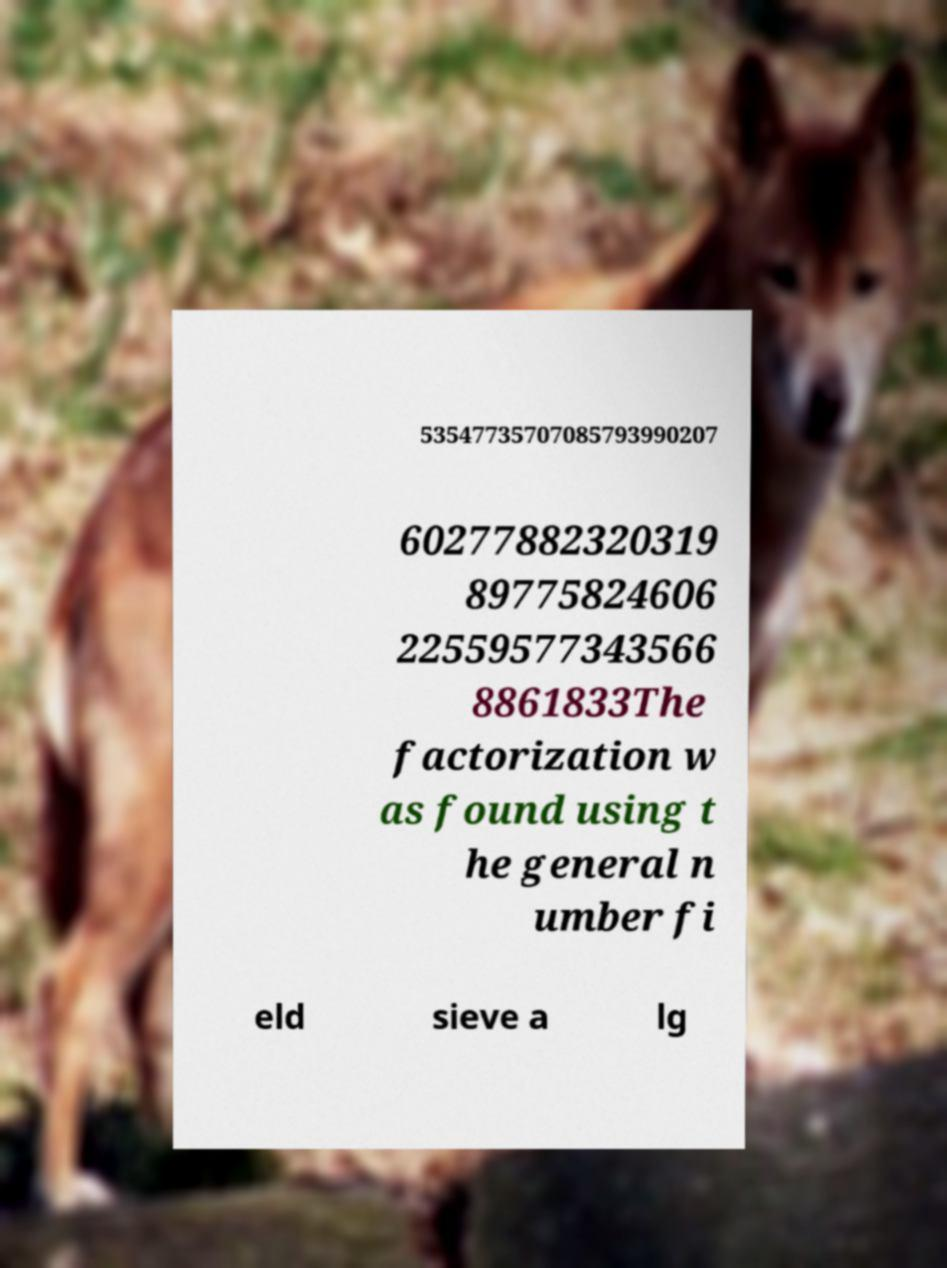I need the written content from this picture converted into text. Can you do that? 53547735707085793990207 60277882320319 89775824606 22559577343566 8861833The factorization w as found using t he general n umber fi eld sieve a lg 